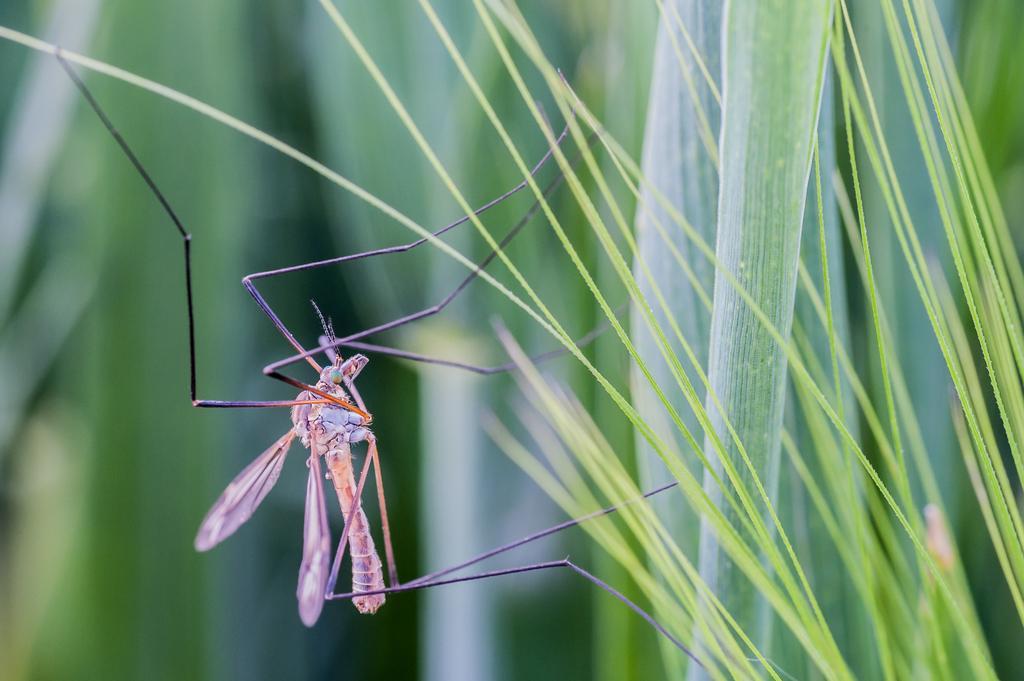Describe this image in one or two sentences. In this image I can see an insect on the grass and the grass is in green color. 